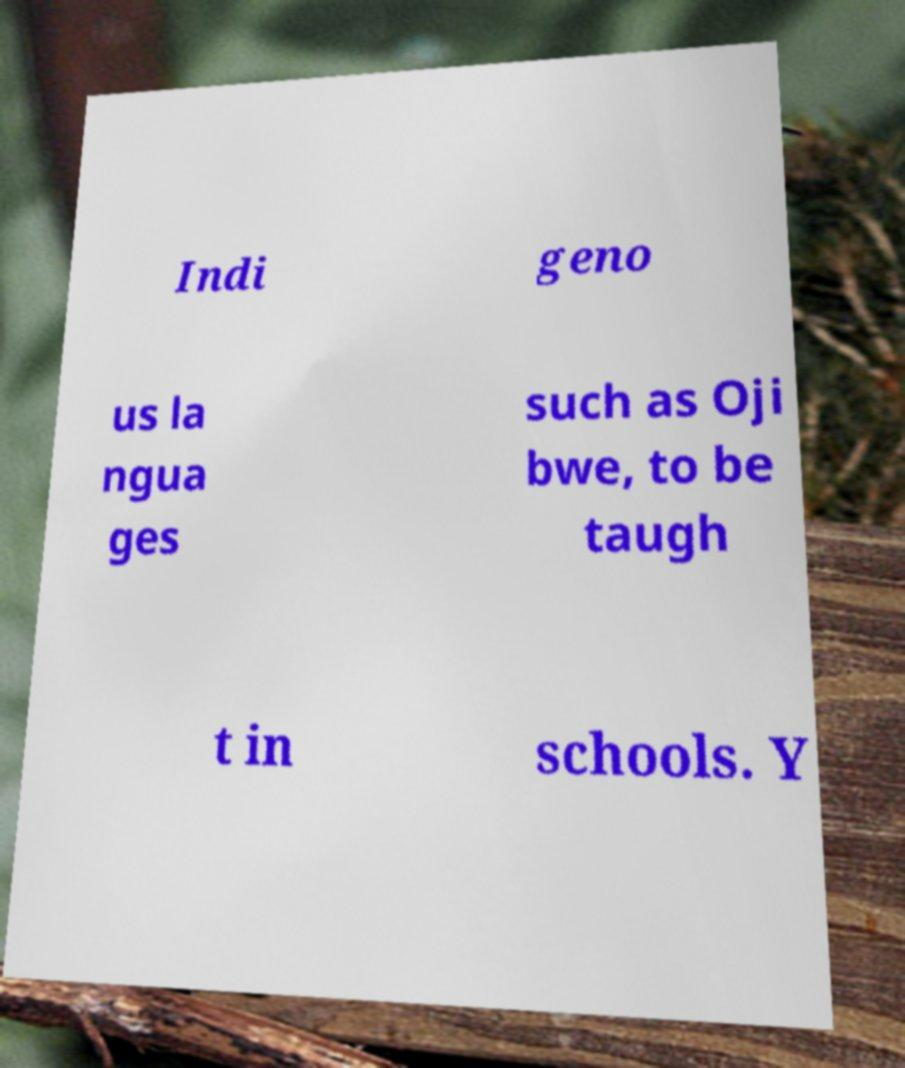Could you extract and type out the text from this image? Indi geno us la ngua ges such as Oji bwe, to be taugh t in schools. Y 